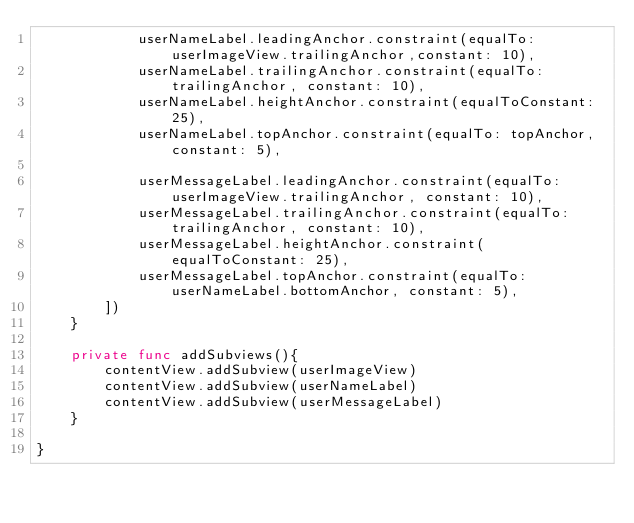<code> <loc_0><loc_0><loc_500><loc_500><_Swift_>            userNameLabel.leadingAnchor.constraint(equalTo: userImageView.trailingAnchor,constant: 10),
            userNameLabel.trailingAnchor.constraint(equalTo: trailingAnchor, constant: 10),
            userNameLabel.heightAnchor.constraint(equalToConstant: 25),
            userNameLabel.topAnchor.constraint(equalTo: topAnchor, constant: 5),
            
            userMessageLabel.leadingAnchor.constraint(equalTo: userImageView.trailingAnchor, constant: 10),
            userMessageLabel.trailingAnchor.constraint(equalTo: trailingAnchor, constant: 10),
            userMessageLabel.heightAnchor.constraint(equalToConstant: 25),
            userMessageLabel.topAnchor.constraint(equalTo: userNameLabel.bottomAnchor, constant: 5),
        ])
    }
    
    private func addSubviews(){
        contentView.addSubview(userImageView)
        contentView.addSubview(userNameLabel)
        contentView.addSubview(userMessageLabel)
    }
    
}
</code> 